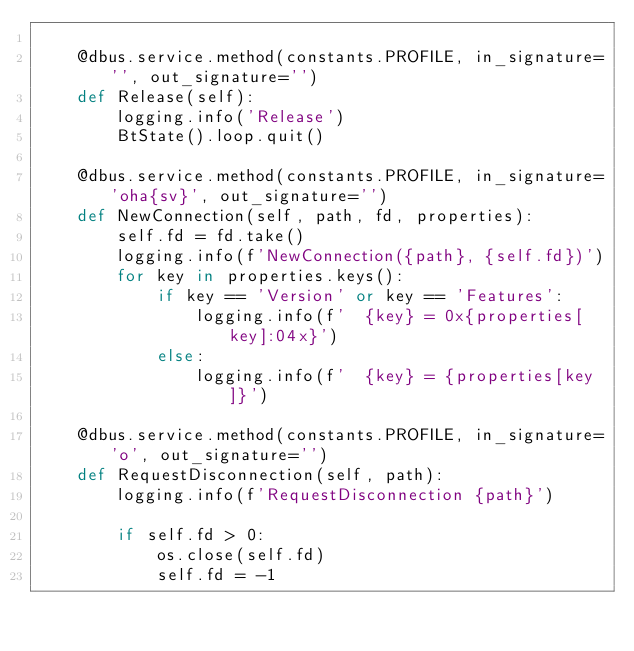Convert code to text. <code><loc_0><loc_0><loc_500><loc_500><_Python_>
    @dbus.service.method(constants.PROFILE, in_signature='', out_signature='')
    def Release(self):
        logging.info('Release')
        BtState().loop.quit()

    @dbus.service.method(constants.PROFILE, in_signature='oha{sv}', out_signature='')
    def NewConnection(self, path, fd, properties):
        self.fd = fd.take()
        logging.info(f'NewConnection({path}, {self.fd})')
        for key in properties.keys():
            if key == 'Version' or key == 'Features':
                logging.info(f'  {key} = 0x{properties[key]:04x}')
            else:
                logging.info(f'  {key} = {properties[key]}')

    @dbus.service.method(constants.PROFILE, in_signature='o', out_signature='')
    def RequestDisconnection(self, path):
        logging.info(f'RequestDisconnection {path}')

        if self.fd > 0:
            os.close(self.fd)
            self.fd = -1</code> 